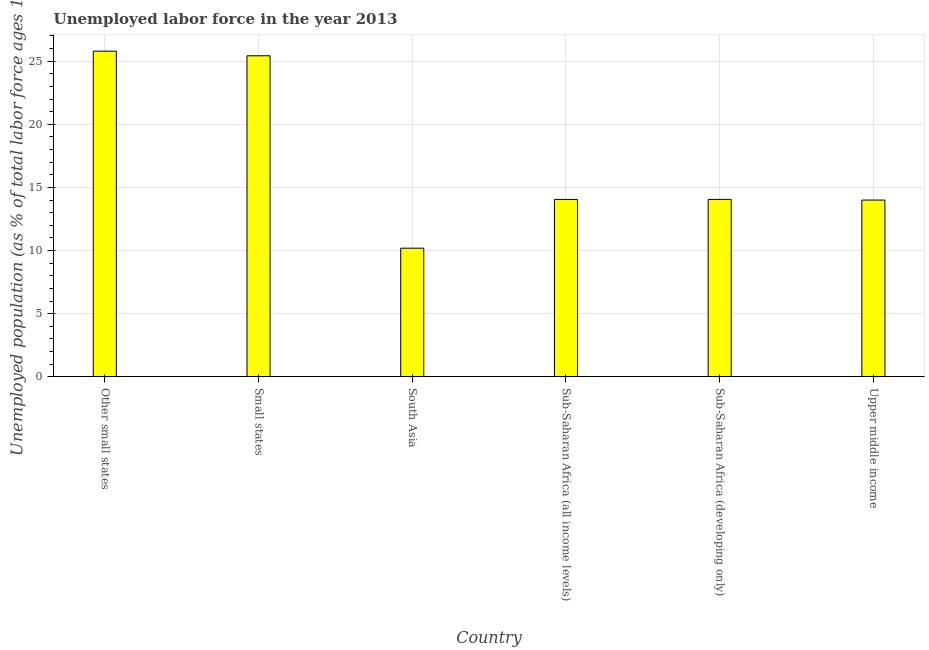Does the graph contain any zero values?
Your response must be concise. No. What is the title of the graph?
Offer a terse response. Unemployed labor force in the year 2013. What is the label or title of the Y-axis?
Provide a succinct answer. Unemployed population (as % of total labor force ages 15-24). What is the total unemployed youth population in Sub-Saharan Africa (all income levels)?
Your response must be concise. 14.05. Across all countries, what is the maximum total unemployed youth population?
Offer a very short reply. 25.79. Across all countries, what is the minimum total unemployed youth population?
Your answer should be compact. 10.19. In which country was the total unemployed youth population maximum?
Your answer should be compact. Other small states. What is the sum of the total unemployed youth population?
Offer a terse response. 103.51. What is the difference between the total unemployed youth population in Sub-Saharan Africa (developing only) and Upper middle income?
Your answer should be compact. 0.05. What is the average total unemployed youth population per country?
Make the answer very short. 17.25. What is the median total unemployed youth population?
Provide a short and direct response. 14.05. In how many countries, is the total unemployed youth population greater than 26 %?
Make the answer very short. 0. What is the ratio of the total unemployed youth population in Other small states to that in Small states?
Make the answer very short. 1.01. Is the total unemployed youth population in Other small states less than that in Upper middle income?
Offer a very short reply. No. Is the difference between the total unemployed youth population in Other small states and South Asia greater than the difference between any two countries?
Keep it short and to the point. Yes. What is the difference between the highest and the second highest total unemployed youth population?
Your answer should be compact. 0.37. Is the sum of the total unemployed youth population in South Asia and Sub-Saharan Africa (all income levels) greater than the maximum total unemployed youth population across all countries?
Provide a succinct answer. No. What is the difference between the highest and the lowest total unemployed youth population?
Ensure brevity in your answer.  15.6. Are all the bars in the graph horizontal?
Give a very brief answer. No. What is the difference between two consecutive major ticks on the Y-axis?
Provide a succinct answer. 5. Are the values on the major ticks of Y-axis written in scientific E-notation?
Ensure brevity in your answer.  No. What is the Unemployed population (as % of total labor force ages 15-24) in Other small states?
Your answer should be compact. 25.79. What is the Unemployed population (as % of total labor force ages 15-24) in Small states?
Provide a succinct answer. 25.42. What is the Unemployed population (as % of total labor force ages 15-24) of South Asia?
Give a very brief answer. 10.19. What is the Unemployed population (as % of total labor force ages 15-24) of Sub-Saharan Africa (all income levels)?
Your answer should be compact. 14.05. What is the Unemployed population (as % of total labor force ages 15-24) of Sub-Saharan Africa (developing only)?
Your response must be concise. 14.05. What is the Unemployed population (as % of total labor force ages 15-24) of Upper middle income?
Give a very brief answer. 14. What is the difference between the Unemployed population (as % of total labor force ages 15-24) in Other small states and Small states?
Your answer should be very brief. 0.37. What is the difference between the Unemployed population (as % of total labor force ages 15-24) in Other small states and South Asia?
Provide a succinct answer. 15.6. What is the difference between the Unemployed population (as % of total labor force ages 15-24) in Other small states and Sub-Saharan Africa (all income levels)?
Your response must be concise. 11.74. What is the difference between the Unemployed population (as % of total labor force ages 15-24) in Other small states and Sub-Saharan Africa (developing only)?
Offer a very short reply. 11.74. What is the difference between the Unemployed population (as % of total labor force ages 15-24) in Other small states and Upper middle income?
Your response must be concise. 11.79. What is the difference between the Unemployed population (as % of total labor force ages 15-24) in Small states and South Asia?
Your answer should be compact. 15.23. What is the difference between the Unemployed population (as % of total labor force ages 15-24) in Small states and Sub-Saharan Africa (all income levels)?
Keep it short and to the point. 11.38. What is the difference between the Unemployed population (as % of total labor force ages 15-24) in Small states and Sub-Saharan Africa (developing only)?
Give a very brief answer. 11.37. What is the difference between the Unemployed population (as % of total labor force ages 15-24) in Small states and Upper middle income?
Provide a succinct answer. 11.42. What is the difference between the Unemployed population (as % of total labor force ages 15-24) in South Asia and Sub-Saharan Africa (all income levels)?
Give a very brief answer. -3.86. What is the difference between the Unemployed population (as % of total labor force ages 15-24) in South Asia and Sub-Saharan Africa (developing only)?
Offer a terse response. -3.86. What is the difference between the Unemployed population (as % of total labor force ages 15-24) in South Asia and Upper middle income?
Your response must be concise. -3.81. What is the difference between the Unemployed population (as % of total labor force ages 15-24) in Sub-Saharan Africa (all income levels) and Sub-Saharan Africa (developing only)?
Make the answer very short. -0. What is the difference between the Unemployed population (as % of total labor force ages 15-24) in Sub-Saharan Africa (all income levels) and Upper middle income?
Provide a succinct answer. 0.05. What is the difference between the Unemployed population (as % of total labor force ages 15-24) in Sub-Saharan Africa (developing only) and Upper middle income?
Offer a very short reply. 0.05. What is the ratio of the Unemployed population (as % of total labor force ages 15-24) in Other small states to that in South Asia?
Offer a very short reply. 2.53. What is the ratio of the Unemployed population (as % of total labor force ages 15-24) in Other small states to that in Sub-Saharan Africa (all income levels)?
Your answer should be compact. 1.84. What is the ratio of the Unemployed population (as % of total labor force ages 15-24) in Other small states to that in Sub-Saharan Africa (developing only)?
Keep it short and to the point. 1.83. What is the ratio of the Unemployed population (as % of total labor force ages 15-24) in Other small states to that in Upper middle income?
Make the answer very short. 1.84. What is the ratio of the Unemployed population (as % of total labor force ages 15-24) in Small states to that in South Asia?
Your response must be concise. 2.5. What is the ratio of the Unemployed population (as % of total labor force ages 15-24) in Small states to that in Sub-Saharan Africa (all income levels)?
Provide a succinct answer. 1.81. What is the ratio of the Unemployed population (as % of total labor force ages 15-24) in Small states to that in Sub-Saharan Africa (developing only)?
Make the answer very short. 1.81. What is the ratio of the Unemployed population (as % of total labor force ages 15-24) in Small states to that in Upper middle income?
Your answer should be compact. 1.82. What is the ratio of the Unemployed population (as % of total labor force ages 15-24) in South Asia to that in Sub-Saharan Africa (all income levels)?
Provide a short and direct response. 0.72. What is the ratio of the Unemployed population (as % of total labor force ages 15-24) in South Asia to that in Sub-Saharan Africa (developing only)?
Provide a short and direct response. 0.72. What is the ratio of the Unemployed population (as % of total labor force ages 15-24) in South Asia to that in Upper middle income?
Your answer should be very brief. 0.73. What is the ratio of the Unemployed population (as % of total labor force ages 15-24) in Sub-Saharan Africa (all income levels) to that in Upper middle income?
Ensure brevity in your answer.  1. 